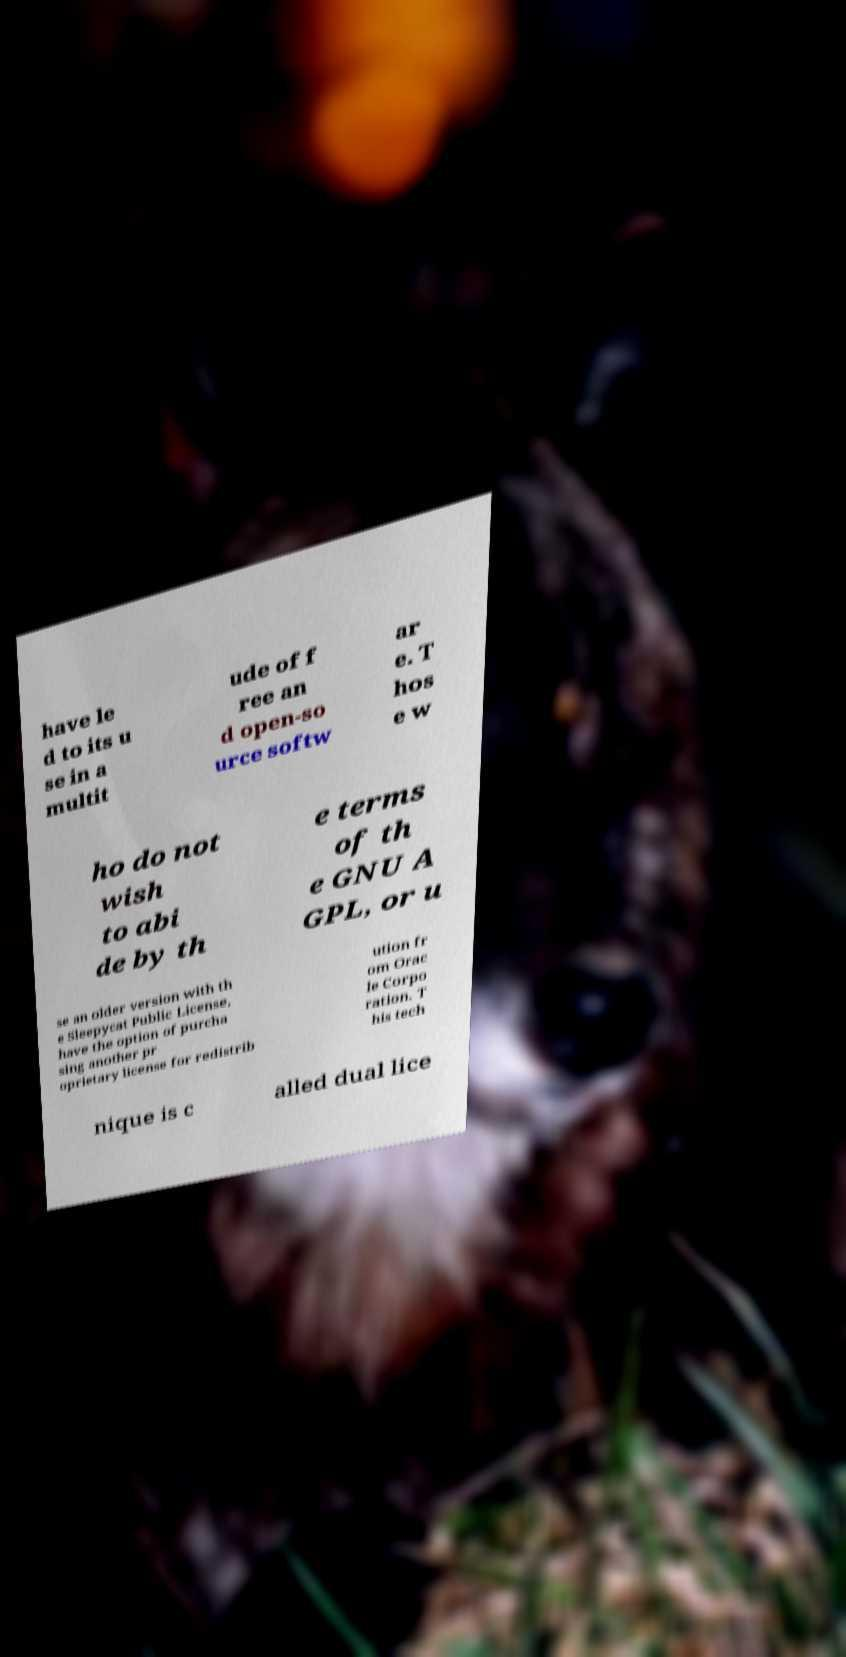What messages or text are displayed in this image? I need them in a readable, typed format. have le d to its u se in a multit ude of f ree an d open-so urce softw ar e. T hos e w ho do not wish to abi de by th e terms of th e GNU A GPL, or u se an older version with th e Sleepycat Public License, have the option of purcha sing another pr oprietary license for redistrib ution fr om Orac le Corpo ration. T his tech nique is c alled dual lice 